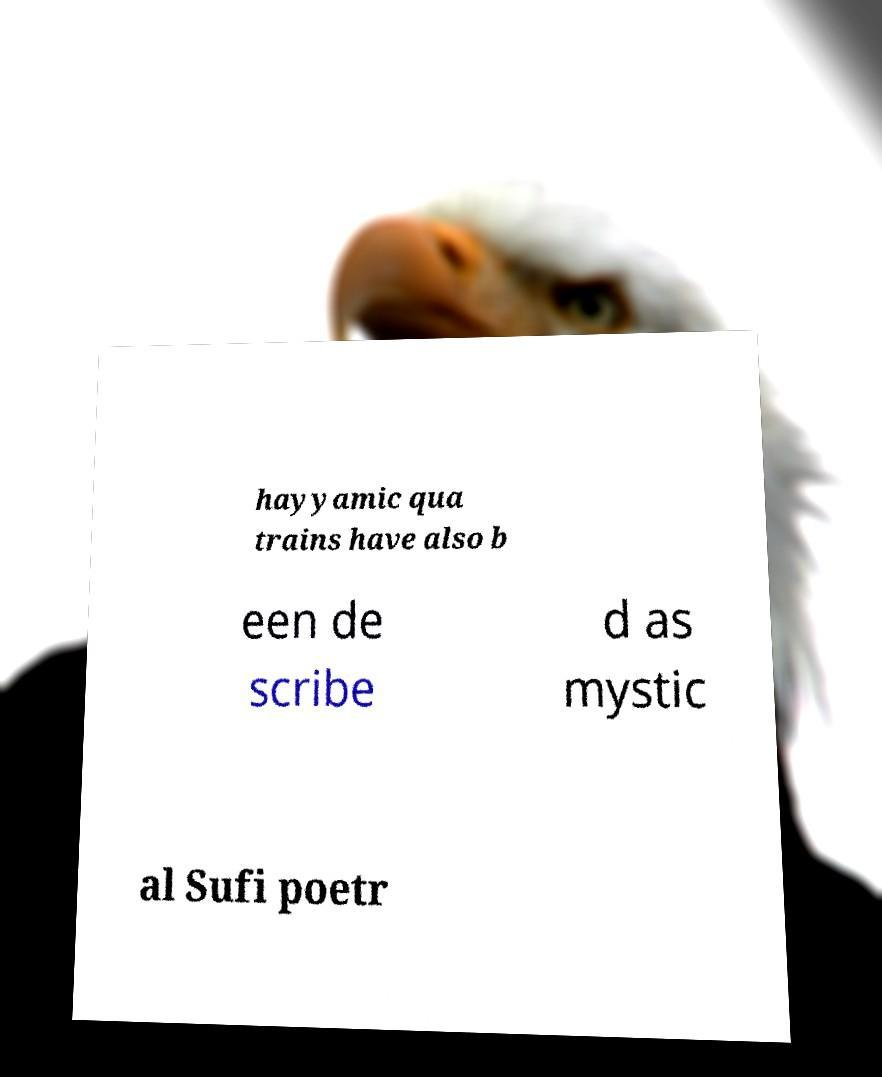Please identify and transcribe the text found in this image. hayyamic qua trains have also b een de scribe d as mystic al Sufi poetr 